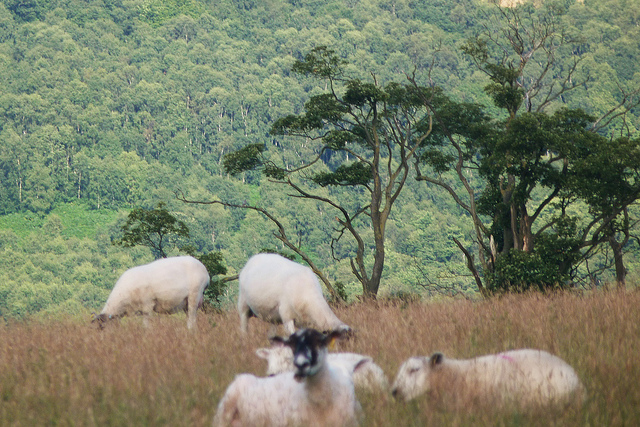<image>What kind of trees are behind the animals? I don't know what kind of trees are behind the animals. They could be elm or oak trees. What kind of trees are behind the animals? I don't know what kind of trees are behind the animals. There can be green foliage, elm, oak or any other kind of trees. 